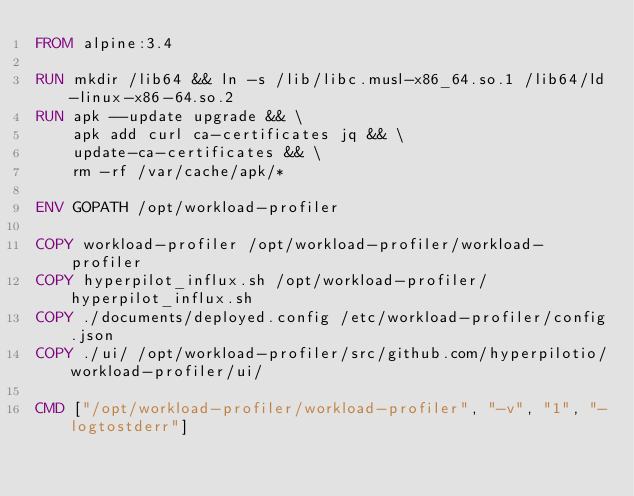<code> <loc_0><loc_0><loc_500><loc_500><_Dockerfile_>FROM alpine:3.4

RUN mkdir /lib64 && ln -s /lib/libc.musl-x86_64.so.1 /lib64/ld-linux-x86-64.so.2
RUN apk --update upgrade && \
    apk add curl ca-certificates jq && \
    update-ca-certificates && \
    rm -rf /var/cache/apk/*

ENV GOPATH /opt/workload-profiler

COPY workload-profiler /opt/workload-profiler/workload-profiler
COPY hyperpilot_influx.sh /opt/workload-profiler/hyperpilot_influx.sh
COPY ./documents/deployed.config /etc/workload-profiler/config.json
COPY ./ui/ /opt/workload-profiler/src/github.com/hyperpilotio/workload-profiler/ui/

CMD ["/opt/workload-profiler/workload-profiler", "-v", "1", "-logtostderr"]</code> 